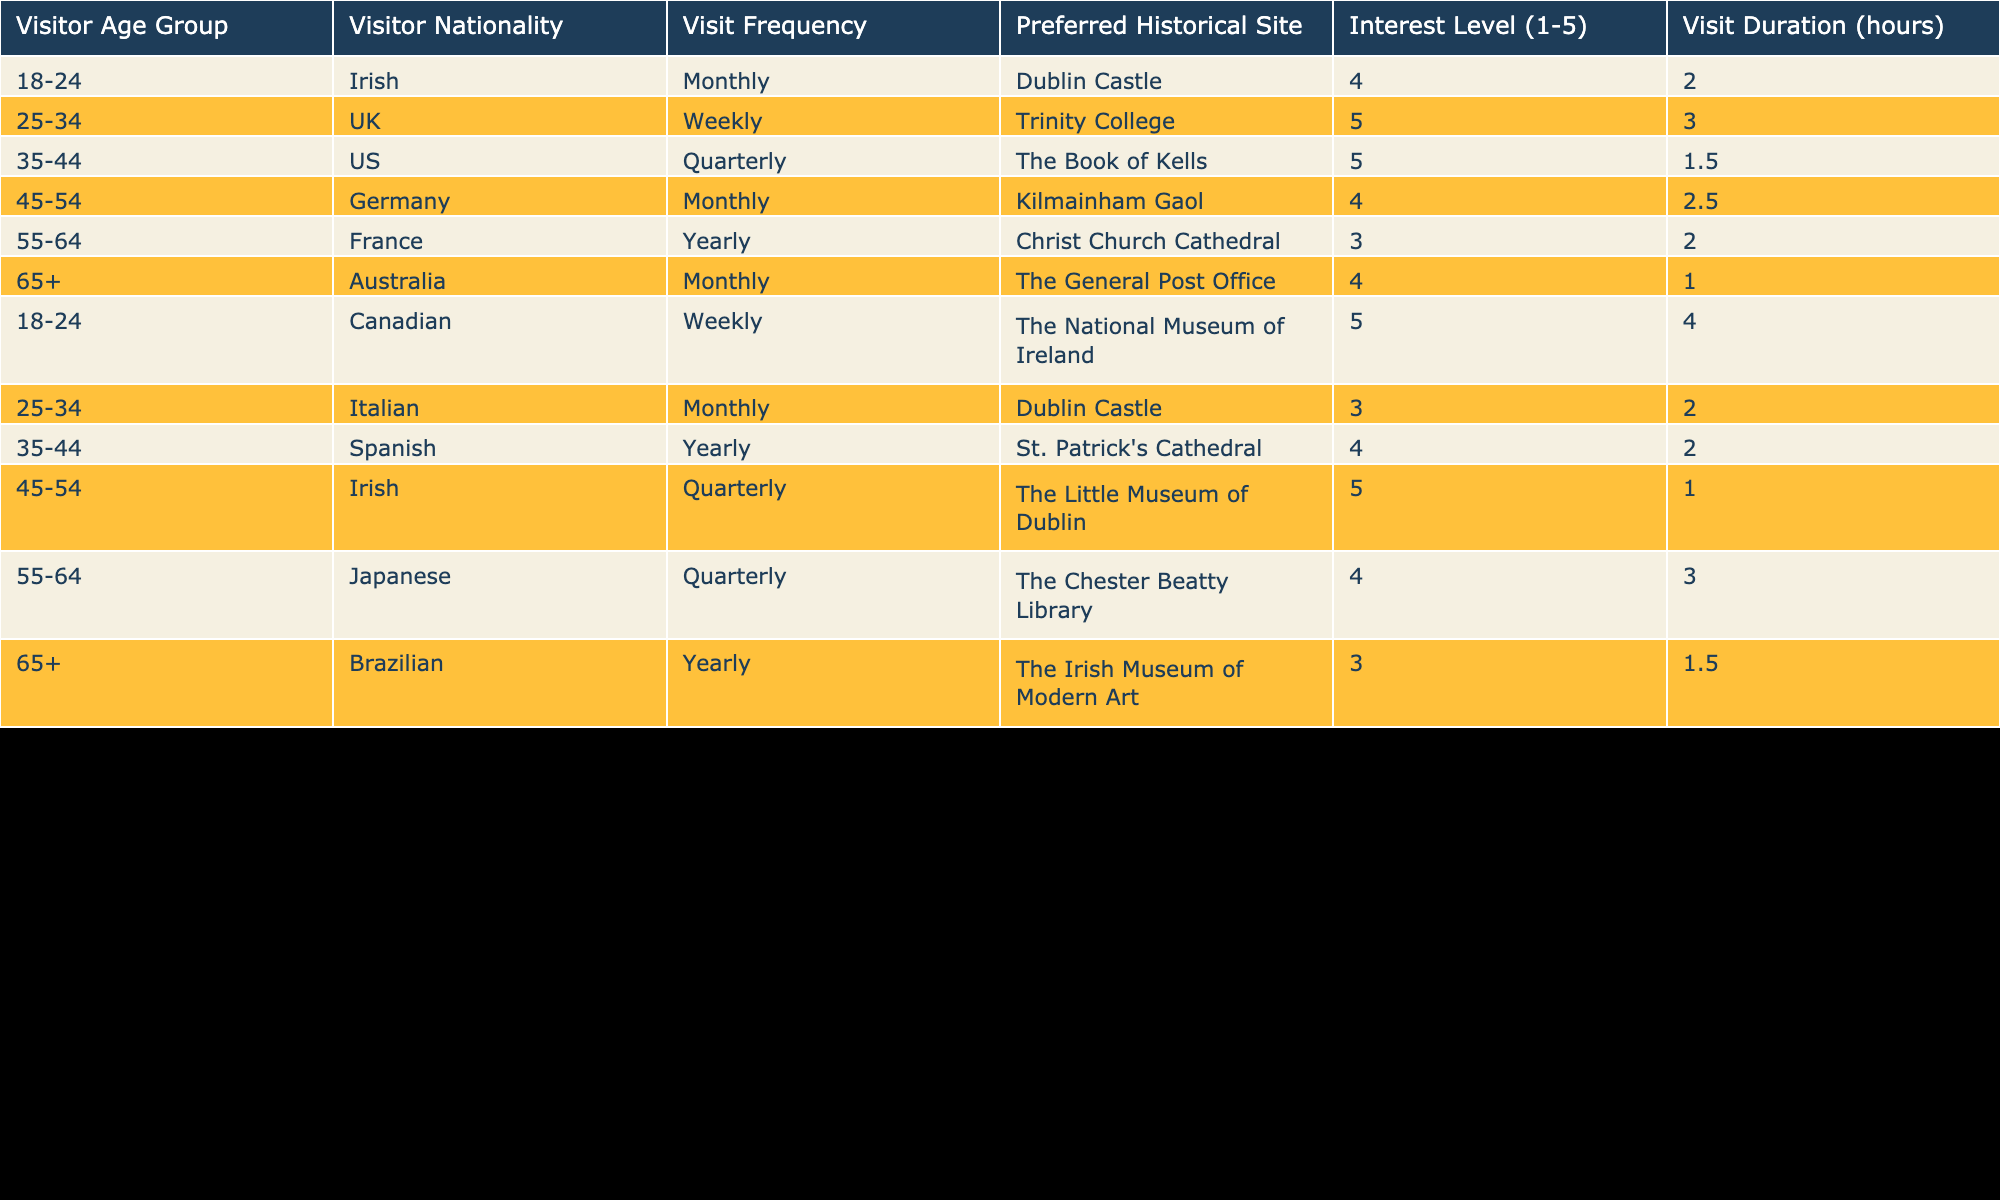What is the preferred historical site for visitors aged 18-24? In the table, you can find two entries for the age group 18-24: one entry lists 'Dublin Castle' and another lists 'The National Museum of Ireland.' Thus, the preferred historical site for this group includes both sites.
Answer: Dublin Castle and The National Museum of Ireland What is the interest level of US visitors? Referring to the entry in the table for US visitors, we see an interest level of 5 for 'The Book of Kells.'
Answer: 5 How many visitors prefer Kilmainham Gaol? Looking at the table, Kilmainham Gaol is preferred by one visitor from Germany aged 45-54 who visits monthly.
Answer: 1 What is the average visit duration for visitors from the UK? The table lists one entry for the UK, stating a visit duration of 3 hours for Trinity College. Since there is only one entry, the average duration is equal to the value itself.
Answer: 3 Do all visitors in the age group 55-64 have a preference for Dublin Castle? In the data, one entry lists Christ Church Cathedral preferred by a visitor from France and another lists The Chester Beatty Library preferred by a visitor from Japan. Since both are different historical sites, not all visitors aged 55-64 prefer Dublin Castle.
Answer: No Which nationality visits Trinity College weekly? There is only one entry for Trinity College indicating that a visitor from the UK visits this site weekly.
Answer: UK What is the visit frequency of Brazilian visitors? The table shows that Brazilian visitors have a yearly visit frequency, specifically listing the 'Irish Museum of Modern Art.'
Answer: Yearly Which historical site has the highest interest level? The table has two entries with the highest interest level of 5, which are 'The Book of Kells' and 'The Little Museum of Dublin.' Therefore, these two historical sites share the highest interest level.
Answer: The Book of Kells and The Little Museum of Dublin What is the total number of visitors aged 35-44? There are two entries for visitors aged 35-44, one from the US and another from Spain. Therefore, the total number of visitors in this age group is 2.
Answer: 2 